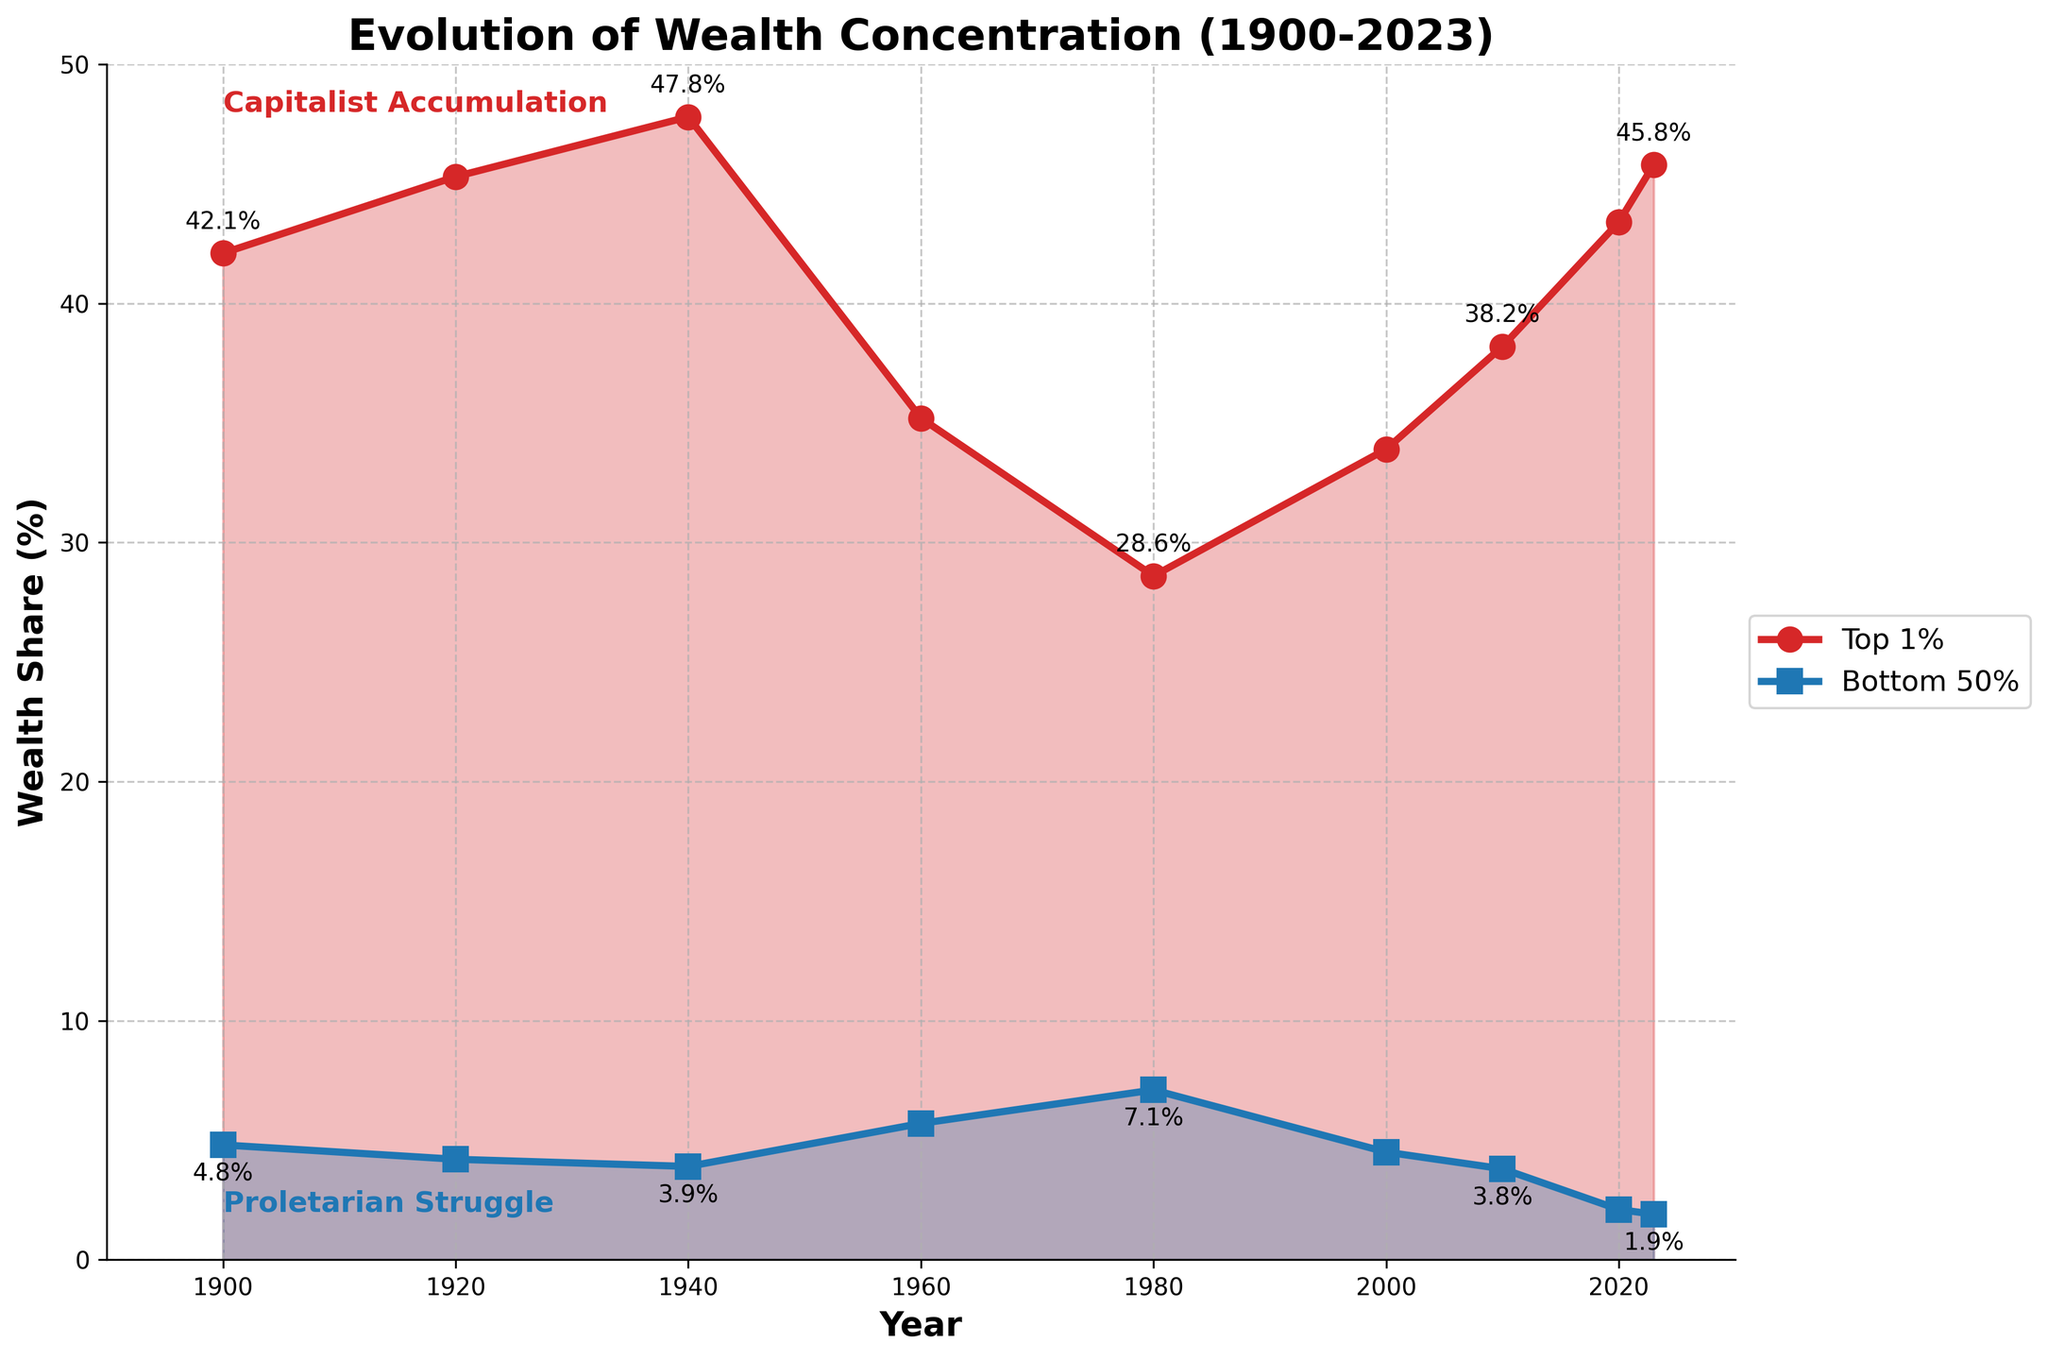What's the highest wealth share of the top 1% over the years? The highest point on the red line represents the maximum wealth share of the top 1%. From the chart, this highest point is reached in 1940.
Answer: 47.8% What's the difference in wealth share of the bottom 50% between 1900 and 2023? To find the difference, subtract the wealth share of the bottom 50% in 2023 from that in 1900: 4.8% (1900) - 1.9% (2023).
Answer: 2.9% Which year had the highest wealth share for the bottom 50%? The highest point on the blue line indicates the highest wealth share for the bottom 50%. In the chart, this occurs around 1980.
Answer: 1980 How did the wealth share of the top 1% change from 1980 to 2000? The wealth share of the top 1% in 1980 is 28.6% and in 2000 is 33.9%. Subtract the former from the latter to find the change: 33.9% - 28.6%.
Answer: 5.3% What is the trend of wealth share for the bottom 50% from 1940 to 2023? Observing the blue line from 1940 to 2023, we see a continuous decline, indicating a downward trend in their wealth share.
Answer: Downward Compare the wealth share of the top 1% in 1920 and 2023. Which one is greater? The wealth shares are 45.3% for 1920 and 45.8% for 2023. Compare these two values.
Answer: 2023 What's the average wealth share of the top 1% between 1900 and 1940? Add the wealth shares from 1900, 1920, and 1940, then divide by 3: (42.1 + 45.3 + 47.8) / 3.
Answer: 45.1% Calculate the average decline rate per decade for the bottom 50%’s wealth share from 1980 to 2020. Find the decline from 1980 (7.1%) to 2020 (2.1%) which is 7.1% - 2.1% = 5%. Then divide by the number of decades (4).
Answer: 1.25% per decade What's the trend for the wealth share of the top 1% from 2000 to 2023? Observing the red line from 2000 to 2023, there is a noticeable increase in the wealth share.
Answer: Upward 